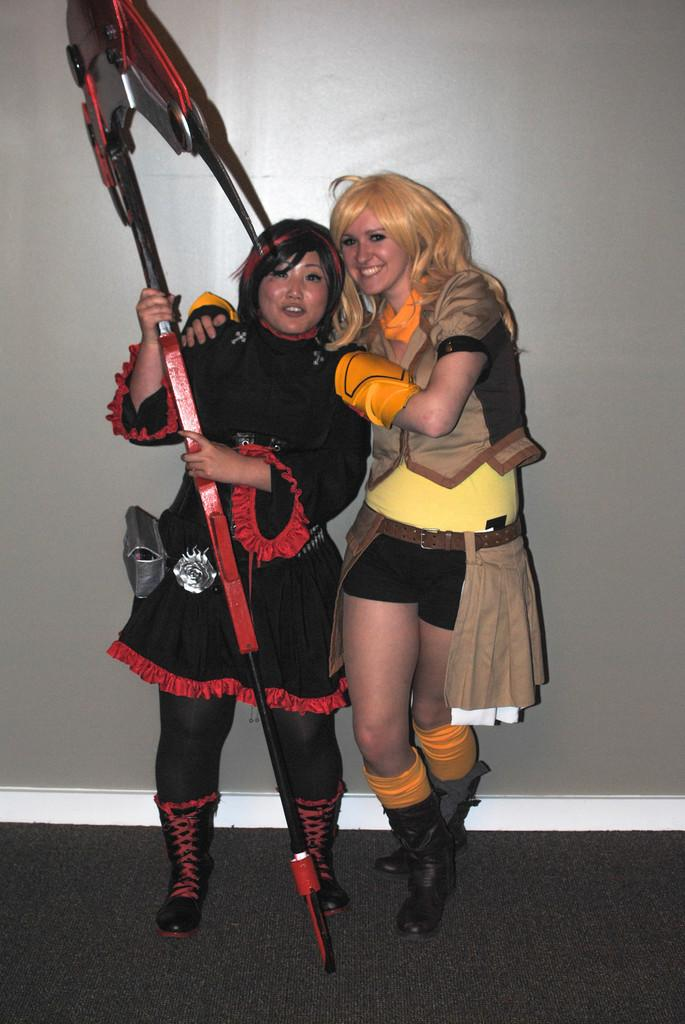How many people are in the image? There are two people in the image. What are the people doing in the image? The people are standing in the image. What can be observed about the people's clothing? The people are wearing different color costumes. What are the people holding in the image? The people are holding something in the image. What is the color of the background in the image? The background of the image is ash colored. What type of hook can be seen in the image? There is no hook present in the image. Can you tell me how much honey is being consumed by the people in the image? There is no honey present in the image, so it cannot be determined how much is being consumed. 